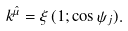Convert formula to latex. <formula><loc_0><loc_0><loc_500><loc_500>k ^ { \hat { \mu } } = \xi \, ( 1 ; \cos \psi _ { j } ) .</formula> 